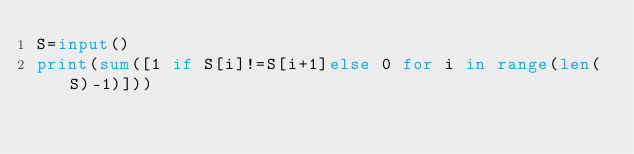Convert code to text. <code><loc_0><loc_0><loc_500><loc_500><_Python_>S=input()
print(sum([1 if S[i]!=S[i+1]else 0 for i in range(len(S)-1)]))</code> 